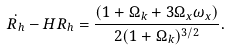<formula> <loc_0><loc_0><loc_500><loc_500>\dot { R _ { h } } - H R _ { h } = \frac { ( 1 + \Omega _ { k } + 3 \Omega _ { x } \omega _ { x } ) } { 2 ( 1 + \Omega _ { k } ) ^ { 3 / 2 } } .</formula> 